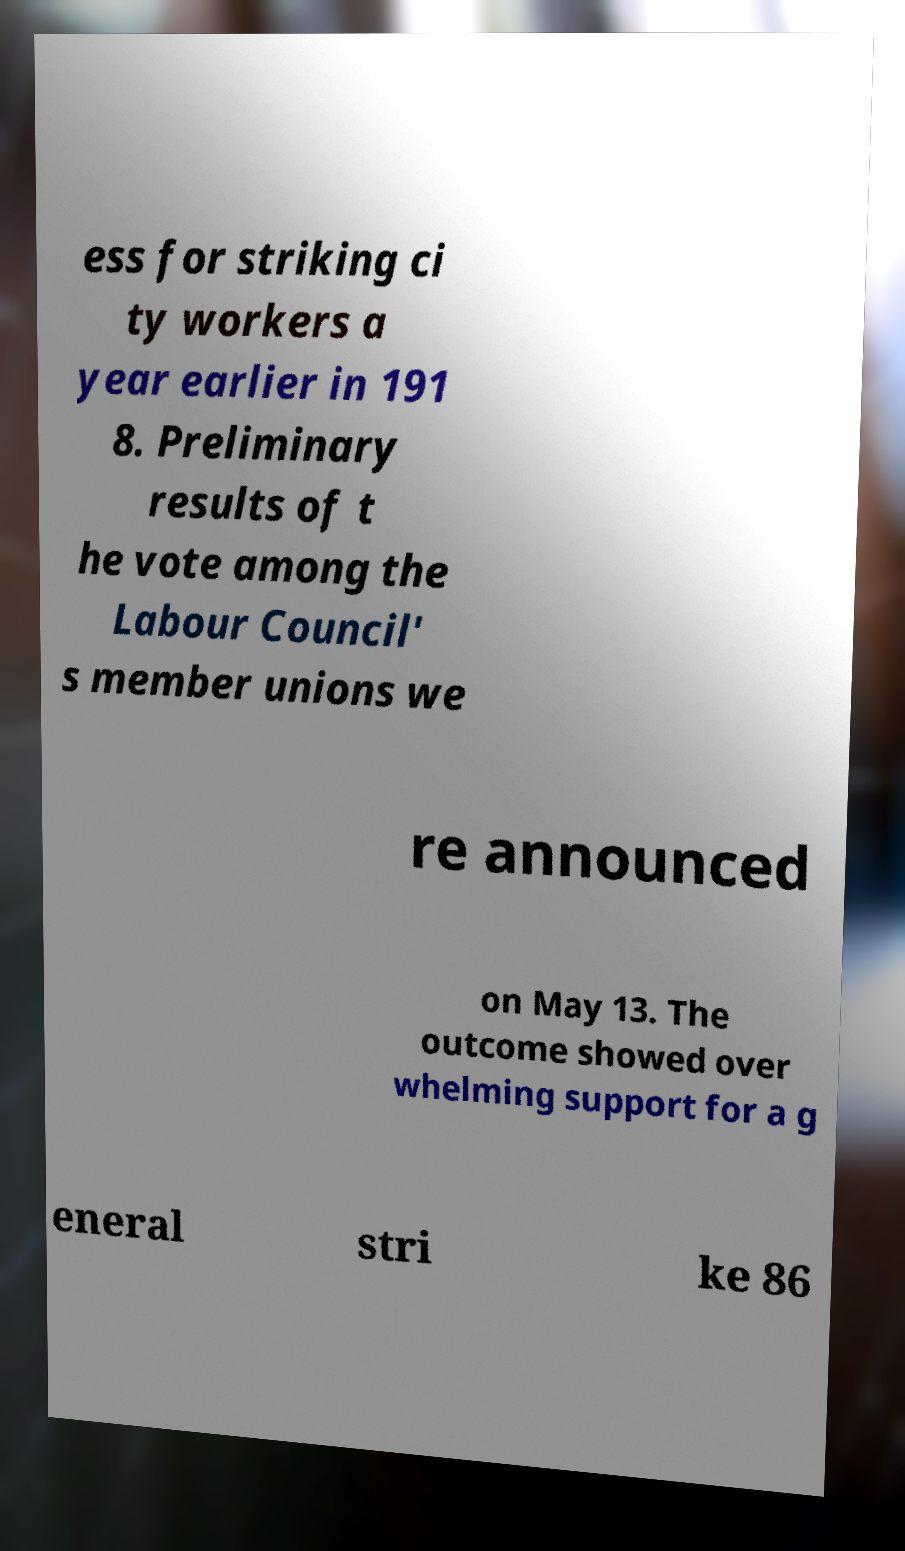There's text embedded in this image that I need extracted. Can you transcribe it verbatim? ess for striking ci ty workers a year earlier in 191 8. Preliminary results of t he vote among the Labour Council' s member unions we re announced on May 13. The outcome showed over whelming support for a g eneral stri ke 86 